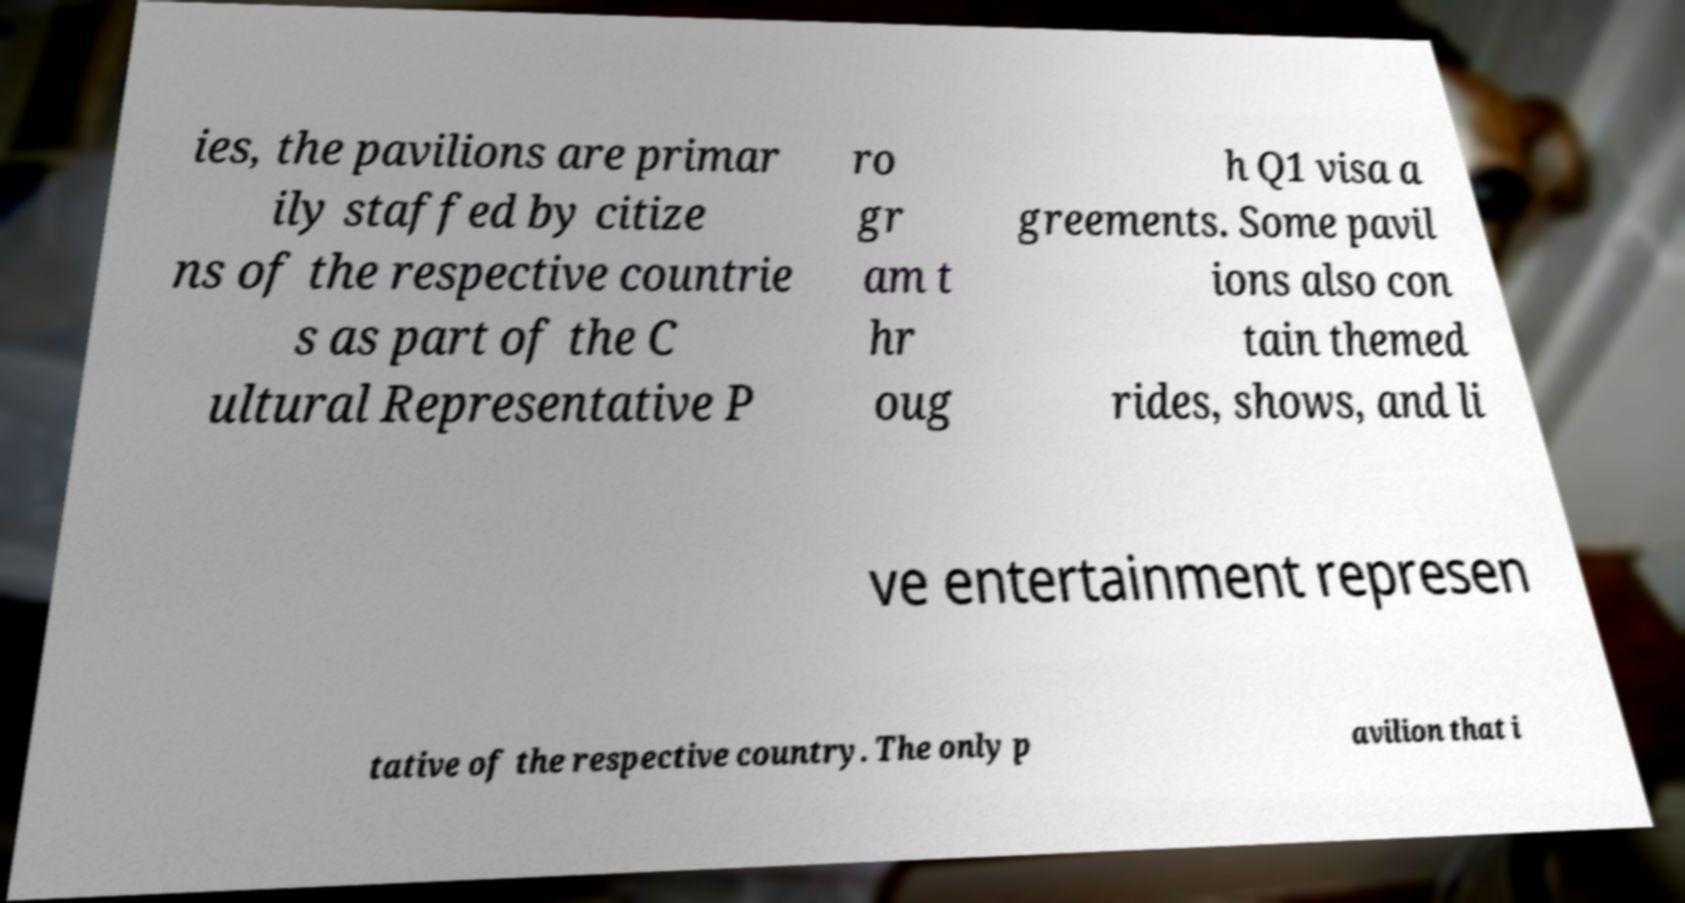What messages or text are displayed in this image? I need them in a readable, typed format. ies, the pavilions are primar ily staffed by citize ns of the respective countrie s as part of the C ultural Representative P ro gr am t hr oug h Q1 visa a greements. Some pavil ions also con tain themed rides, shows, and li ve entertainment represen tative of the respective country. The only p avilion that i 